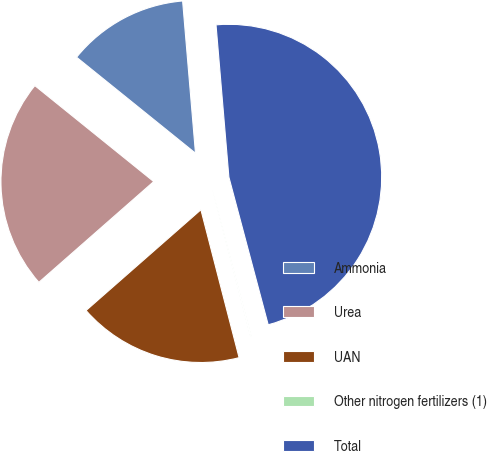Convert chart to OTSL. <chart><loc_0><loc_0><loc_500><loc_500><pie_chart><fcel>Ammonia<fcel>Urea<fcel>UAN<fcel>Other nitrogen fertilizers (1)<fcel>Total<nl><fcel>12.85%<fcel>22.27%<fcel>17.56%<fcel>0.12%<fcel>47.2%<nl></chart> 